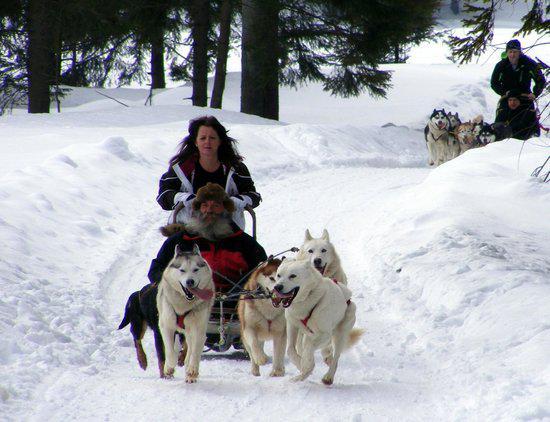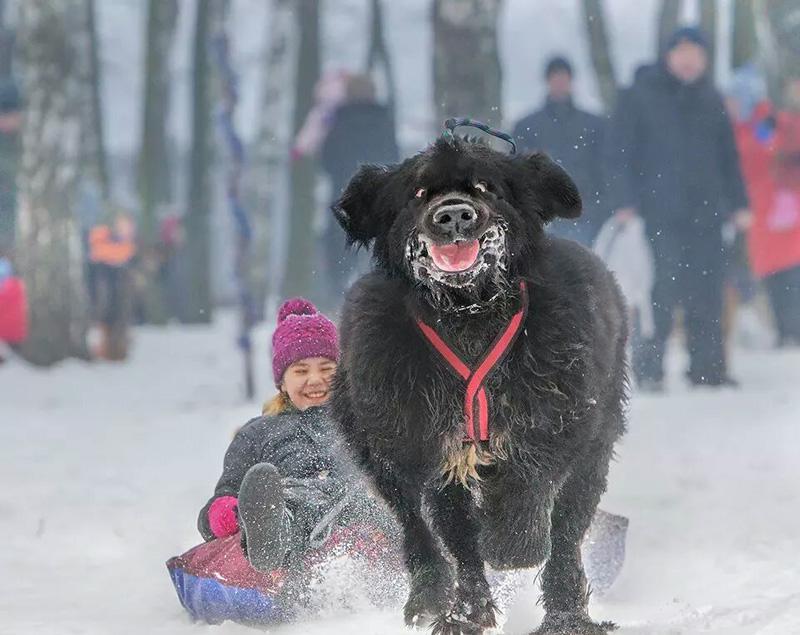The first image is the image on the left, the second image is the image on the right. Considering the images on both sides, is "An image includes a child in a dark jacket leaning forward as he pulls a sled carrying one upright sitting husky on it across the snow." valid? Answer yes or no. No. The first image is the image on the left, the second image is the image on the right. Given the left and right images, does the statement "In the right image, there's at least one instance of a child pulling a dog on a sled." hold true? Answer yes or no. No. 